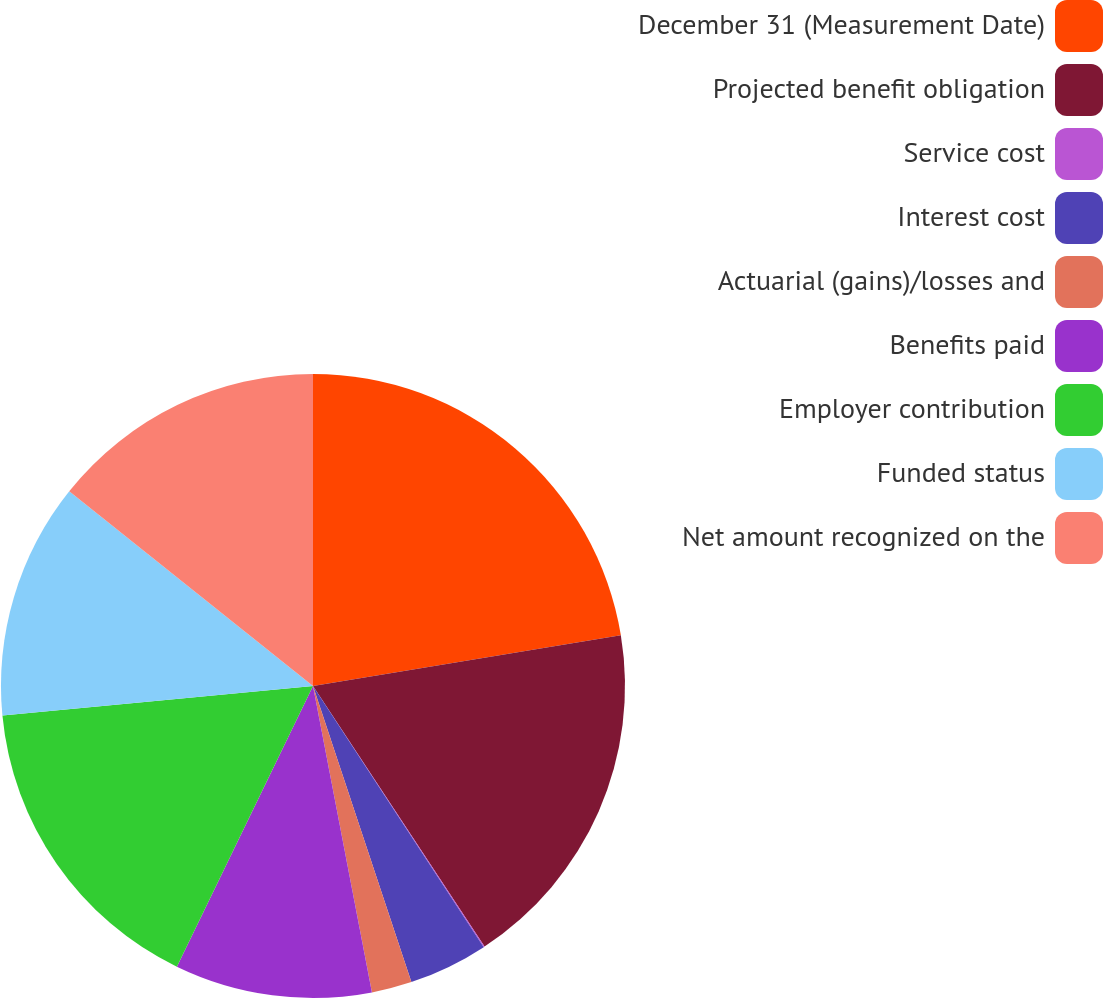Convert chart to OTSL. <chart><loc_0><loc_0><loc_500><loc_500><pie_chart><fcel>December 31 (Measurement Date)<fcel>Projected benefit obligation<fcel>Service cost<fcel>Interest cost<fcel>Actuarial (gains)/losses and<fcel>Benefits paid<fcel>Employer contribution<fcel>Funded status<fcel>Net amount recognized on the<nl><fcel>22.4%<fcel>18.33%<fcel>0.05%<fcel>4.11%<fcel>2.08%<fcel>10.21%<fcel>16.3%<fcel>12.24%<fcel>14.27%<nl></chart> 